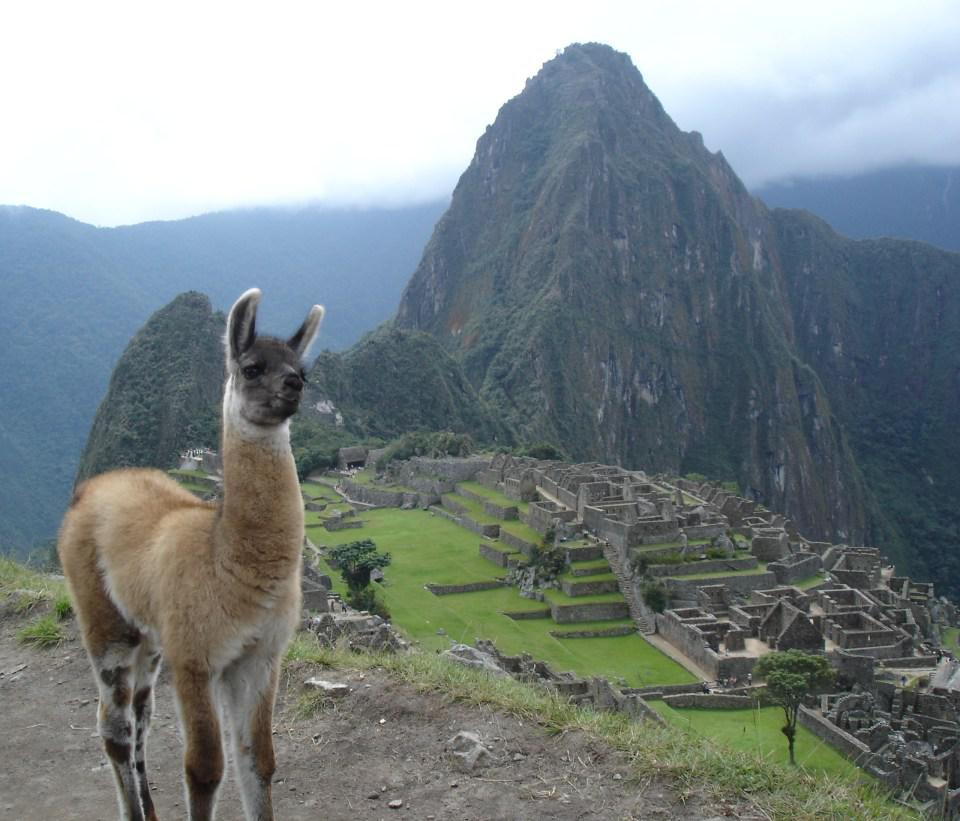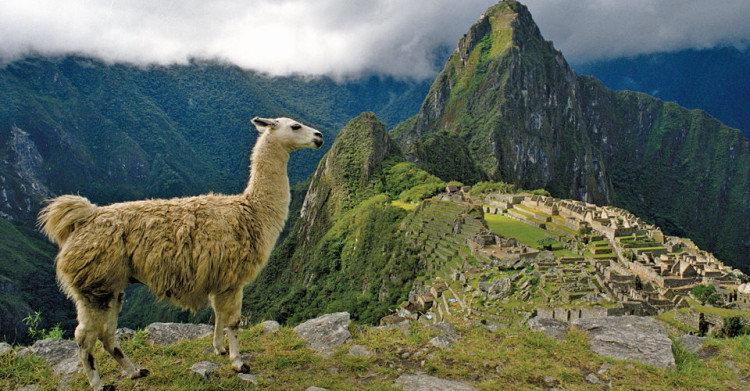The first image is the image on the left, the second image is the image on the right. Given the left and right images, does the statement "The left image features a llama with head angled forward, standing in the foreground on the left, with mountains and mazelike structures behind it." hold true? Answer yes or no. Yes. 